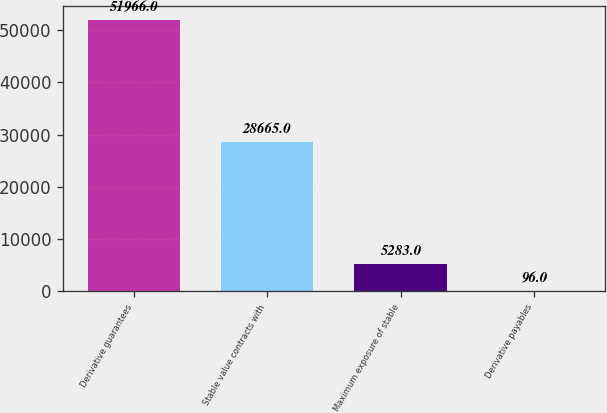Convert chart to OTSL. <chart><loc_0><loc_0><loc_500><loc_500><bar_chart><fcel>Derivative guarantees<fcel>Stable value contracts with<fcel>Maximum exposure of stable<fcel>Derivative payables<nl><fcel>51966<fcel>28665<fcel>5283<fcel>96<nl></chart> 